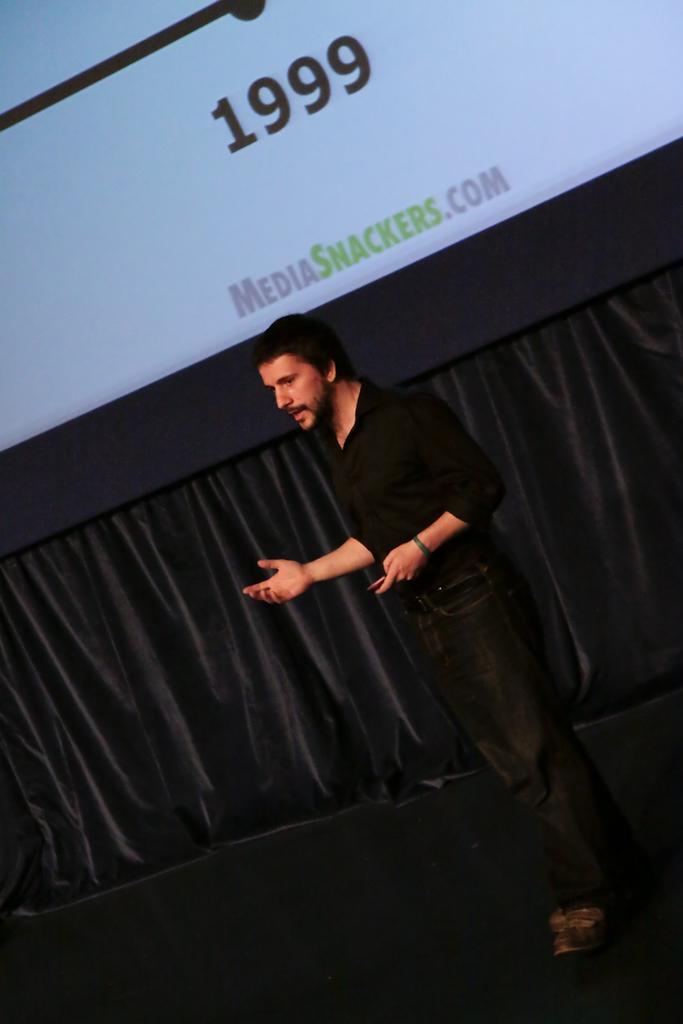Please provide a concise description of this image. In this picture there is a man who is wearing black shirt, match, trouser and shoes. He is standing on the stage. Behind him I can see the black color cloth. At the top I can see the projector screen. 